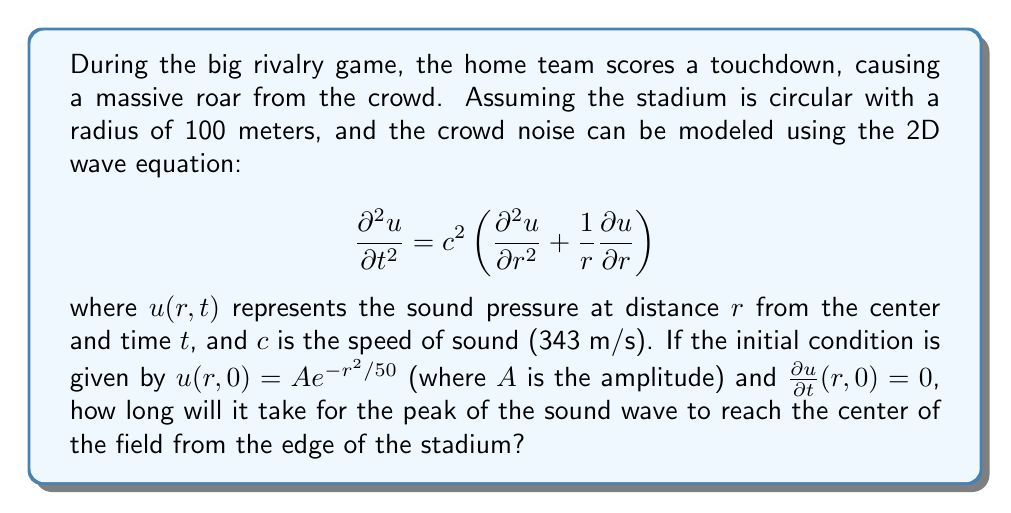Can you solve this math problem? Let's approach this step-by-step:

1) The wave equation given describes the propagation of sound in a circular stadium. The initial condition $u(r,0) = A e^{-r^2/50}$ represents the initial distribution of sound pressure, with the maximum at the edge of the stadium (r = 100 m).

2) To find when the peak reaches the center, we need to determine how long it takes for the wave to travel from r = 100 m to r = 0 m.

3) In a circular geometry, waves propagate radially. The distance the wave needs to travel is the radius of the stadium, which is 100 m.

4) The speed of the wave is given as c = 343 m/s (the speed of sound in air).

5) Using the basic equation for time, distance, and speed:

   $$t = \frac{distance}{speed}$$

6) Substituting our values:

   $$t = \frac{100 \text{ m}}{343 \text{ m/s}}$$

7) Calculating:

   $$t \approx 0.2915 \text{ seconds}$$

Thus, it will take approximately 0.2915 seconds for the peak of the sound wave to reach the center of the field from the edge of the stadium.
Answer: 0.2915 seconds 